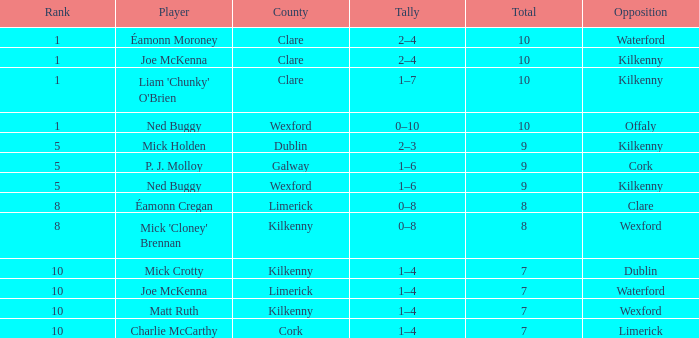What is galway county's total? 9.0. 